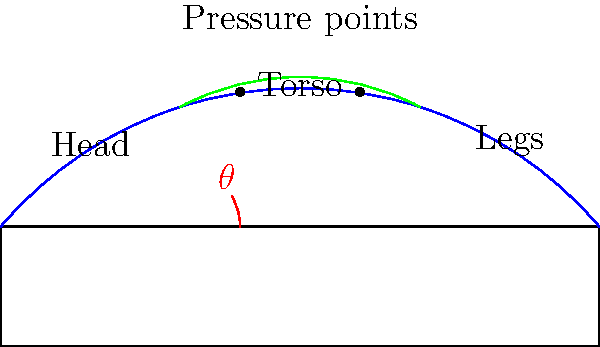For a senior with visual impairments, what is the recommended angle $\theta$ for the head section of an adjustable bed to provide optimal comfort and pressure relief, particularly for the upper body? To determine the optimal angle for the head section of an adjustable bed, we need to consider several factors:

1. Pressure relief: Elevating the head section helps redistribute weight and reduce pressure on the lower back and buttocks.

2. Respiratory function: A slightly elevated position can improve breathing, especially for seniors with respiratory issues.

3. Circulation: Raising the upper body can enhance blood flow and reduce swelling in the legs.

4. Comfort: The angle should allow for comfortable reading, watching TV, or conversing without straining the neck.

5. Visual impairment considerations: A more upright position may help with spatial awareness and reduce disorientation.

Based on these factors and ergonomic studies:

- A range of 30° to 45° is generally recommended for the head section.
- Within this range, 30° is often considered optimal for extended periods as it provides a balance between comfort and pressure relief.
- This angle helps maintain proper spinal alignment while reducing pressure on the lower back and buttocks.
- It also facilitates easier breathing and better digestion.

For seniors with visual impairments, a 30° angle can help with:
- Improved spatial awareness
- Easier transitions between lying down and sitting up
- Better positioning for tactile activities or listening to audio content

Therefore, the recommended angle $\theta$ for optimal comfort and pressure relief is approximately 30°.
Answer: 30° 